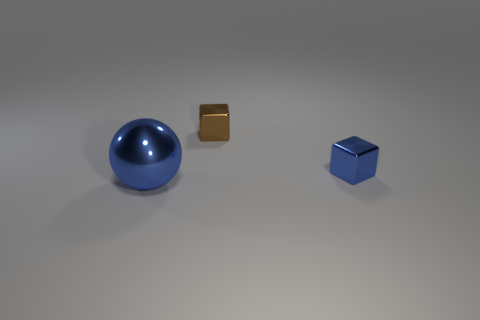How many balls are big blue objects or green rubber things?
Offer a terse response. 1. What is the color of the other cube that is the same size as the brown cube?
Offer a terse response. Blue. There is a shiny object left of the cube behind the small blue metallic thing; what is its shape?
Provide a short and direct response. Sphere. Is the size of the blue shiny object to the right of the metal ball the same as the large blue thing?
Offer a terse response. No. What number of other things are there of the same material as the blue sphere
Make the answer very short. 2. What number of blue objects are metallic things or shiny blocks?
Give a very brief answer. 2. What is the size of the other object that is the same color as the big thing?
Make the answer very short. Small. What number of blue spheres are behind the large ball?
Offer a very short reply. 0. What is the size of the blue metal cube that is to the right of the tiny metal thing that is on the left side of the blue metallic thing that is behind the big shiny ball?
Provide a short and direct response. Small. There is a metal object on the right side of the tiny thing that is behind the blue block; is there a small brown block behind it?
Your response must be concise. Yes. 